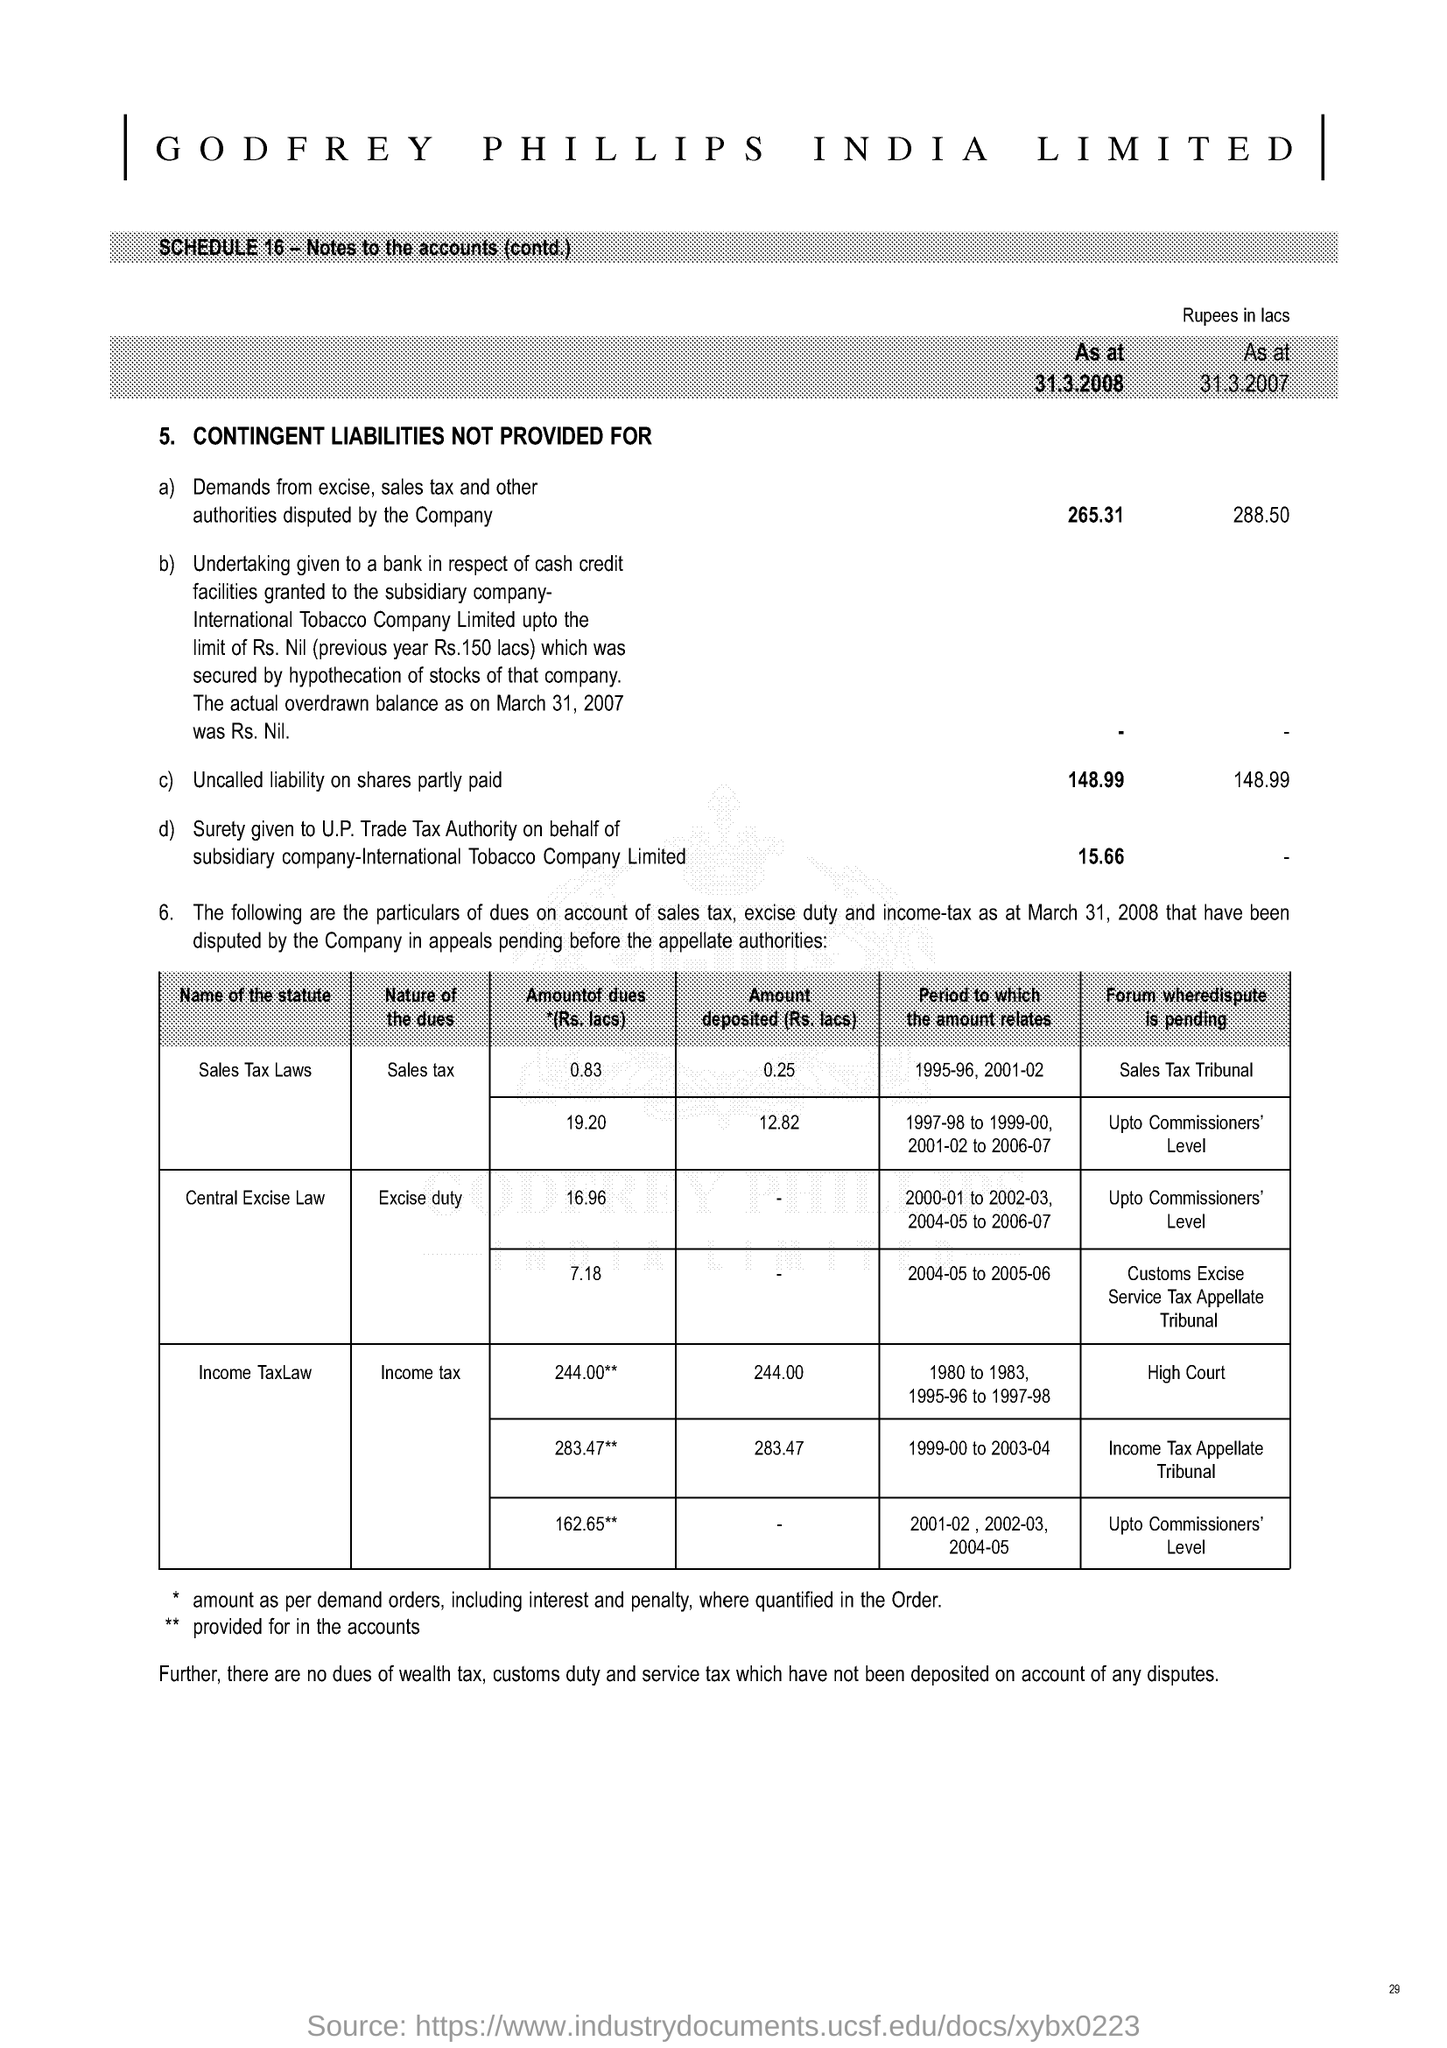How much Uncalled liability on shares partly paid at 31-3-2007 ?
Offer a terse response. 148.99. 